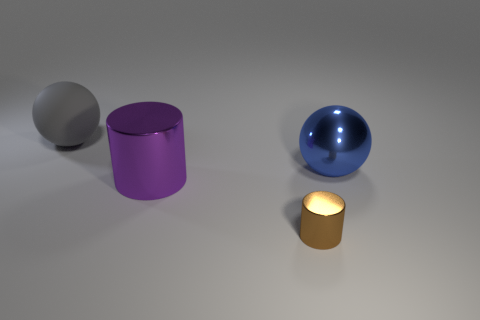What material is the ball that is on the left side of the big ball that is in front of the object that is to the left of the large purple metallic cylinder?
Make the answer very short. Rubber. Are there fewer big blue metal things than tiny green spheres?
Make the answer very short. No. Are the small brown object and the gray thing made of the same material?
Offer a very short reply. No. There is a cylinder that is behind the small brown metal cylinder; is it the same color as the metal sphere?
Provide a succinct answer. No. There is a large object to the right of the brown thing; how many large shiny spheres are right of it?
Ensure brevity in your answer.  0. What color is the other rubber thing that is the same size as the blue object?
Provide a short and direct response. Gray. There is a thing that is on the left side of the big purple cylinder; what material is it?
Ensure brevity in your answer.  Rubber. What is the big object that is left of the blue metallic sphere and right of the big matte sphere made of?
Keep it short and to the point. Metal. There is a ball that is right of the gray matte object; is its size the same as the gray rubber sphere?
Make the answer very short. Yes. What is the shape of the large rubber object?
Provide a short and direct response. Sphere. 